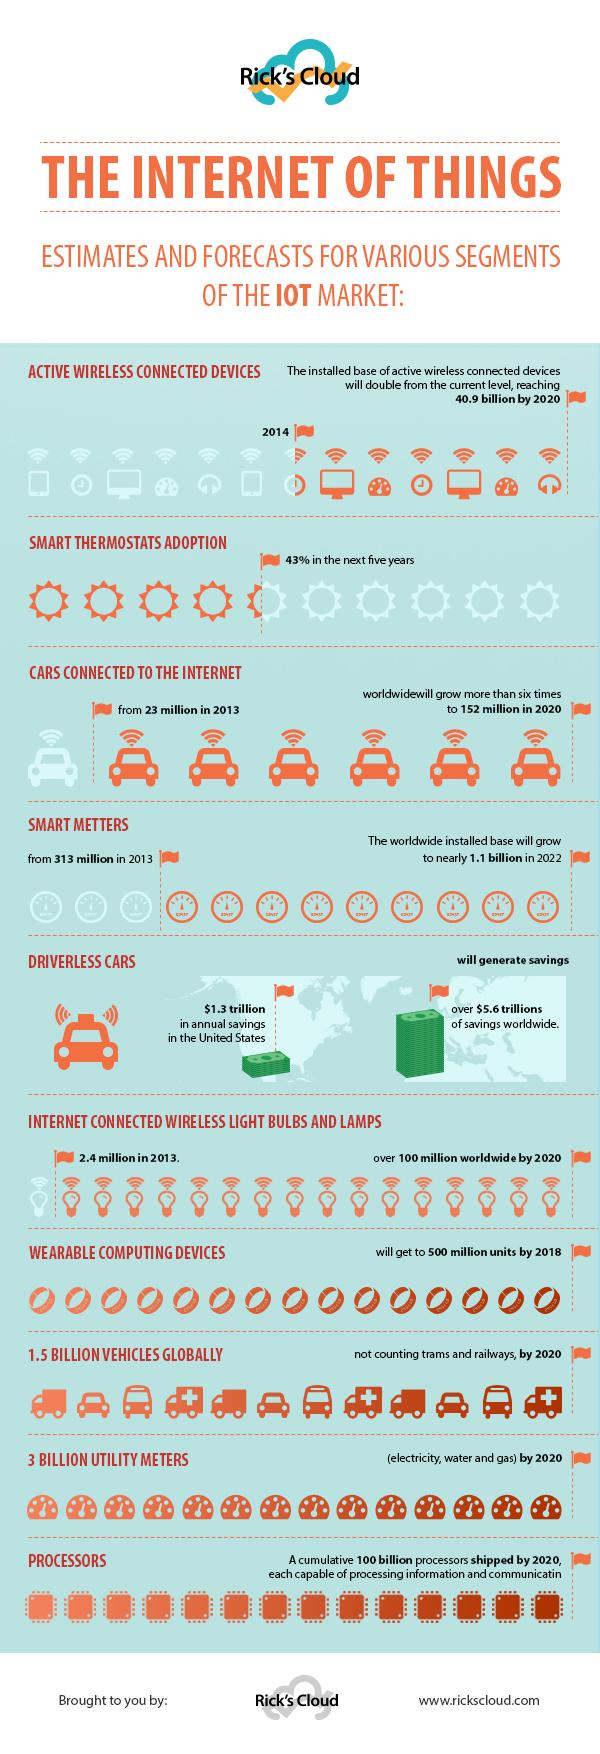Draw attention to some important aspects in this diagram. By 2020, it is projected that the number of interconnected wireless lights and bulbs, as well as lamps, will increase by 97.7 million from the year 2013. According to projections, the number of smart meters is expected to increase from 2013 to 2022, reaching a total of 1,09,68,70,000 billion. The document lists 10 segments of the IOT market. By 2020, it is projected that the number of cars with internet connectivity will increase by 129 million, representing a significant increase in the number of vehicles equipped with this technology. 